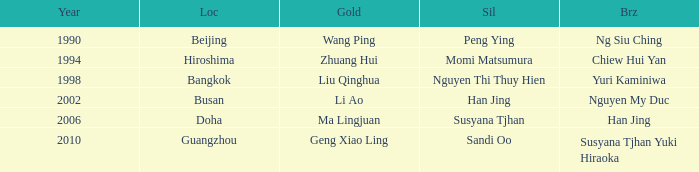What Silver has a Golf of Li AO? Han Jing. 